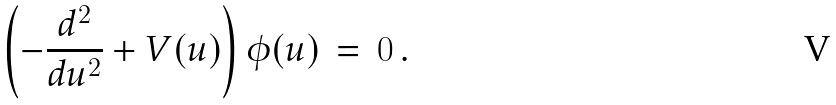<formula> <loc_0><loc_0><loc_500><loc_500>\left ( - \frac { d ^ { 2 } } { d u ^ { 2 } } + V ( u ) \right ) \phi ( u ) \, = \, 0 \, .</formula> 